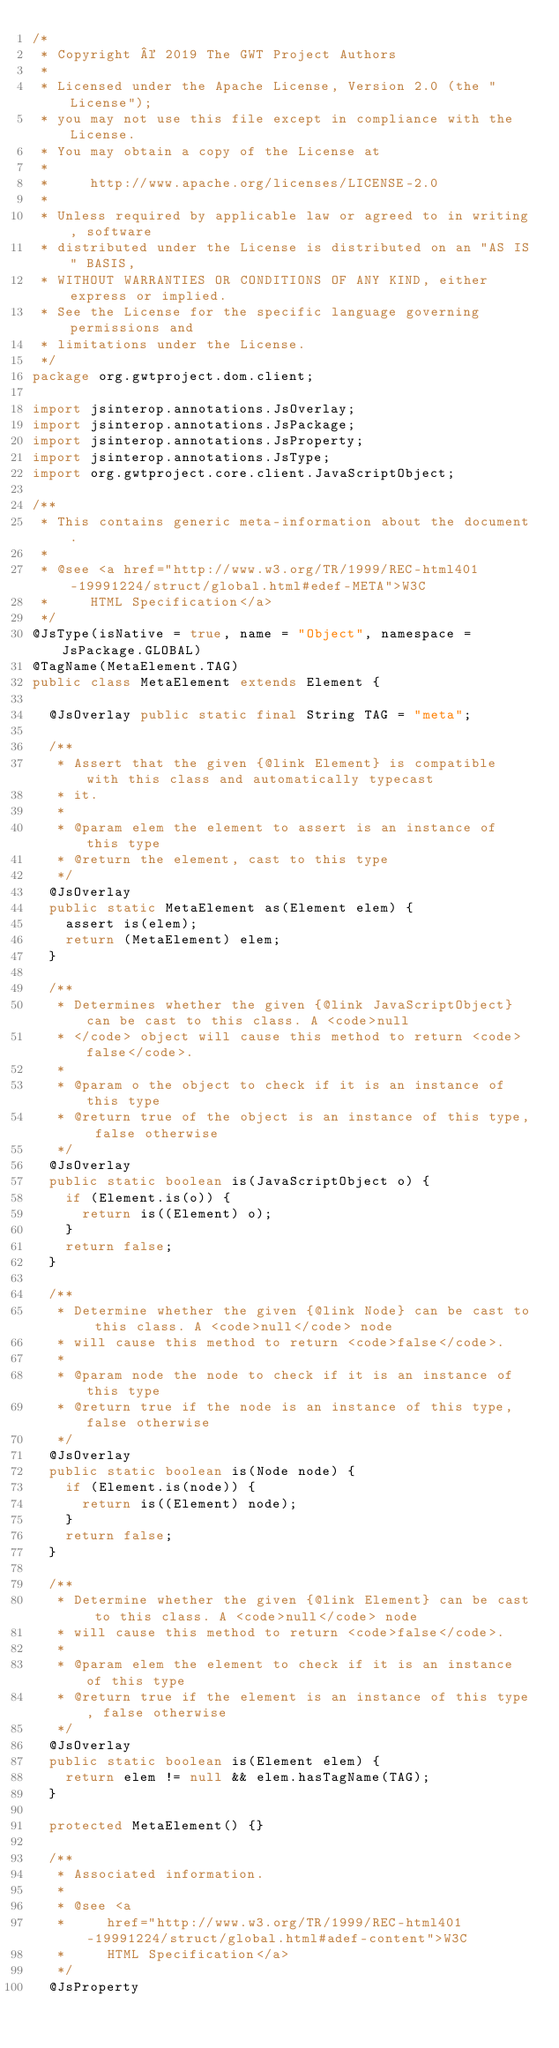<code> <loc_0><loc_0><loc_500><loc_500><_Java_>/*
 * Copyright © 2019 The GWT Project Authors
 *
 * Licensed under the Apache License, Version 2.0 (the "License");
 * you may not use this file except in compliance with the License.
 * You may obtain a copy of the License at
 *
 *     http://www.apache.org/licenses/LICENSE-2.0
 *
 * Unless required by applicable law or agreed to in writing, software
 * distributed under the License is distributed on an "AS IS" BASIS,
 * WITHOUT WARRANTIES OR CONDITIONS OF ANY KIND, either express or implied.
 * See the License for the specific language governing permissions and
 * limitations under the License.
 */
package org.gwtproject.dom.client;

import jsinterop.annotations.JsOverlay;
import jsinterop.annotations.JsPackage;
import jsinterop.annotations.JsProperty;
import jsinterop.annotations.JsType;
import org.gwtproject.core.client.JavaScriptObject;

/**
 * This contains generic meta-information about the document.
 *
 * @see <a href="http://www.w3.org/TR/1999/REC-html401-19991224/struct/global.html#edef-META">W3C
 *     HTML Specification</a>
 */
@JsType(isNative = true, name = "Object", namespace = JsPackage.GLOBAL)
@TagName(MetaElement.TAG)
public class MetaElement extends Element {

  @JsOverlay public static final String TAG = "meta";

  /**
   * Assert that the given {@link Element} is compatible with this class and automatically typecast
   * it.
   *
   * @param elem the element to assert is an instance of this type
   * @return the element, cast to this type
   */
  @JsOverlay
  public static MetaElement as(Element elem) {
    assert is(elem);
    return (MetaElement) elem;
  }

  /**
   * Determines whether the given {@link JavaScriptObject} can be cast to this class. A <code>null
   * </code> object will cause this method to return <code>false</code>.
   *
   * @param o the object to check if it is an instance of this type
   * @return true of the object is an instance of this type, false otherwise
   */
  @JsOverlay
  public static boolean is(JavaScriptObject o) {
    if (Element.is(o)) {
      return is((Element) o);
    }
    return false;
  }

  /**
   * Determine whether the given {@link Node} can be cast to this class. A <code>null</code> node
   * will cause this method to return <code>false</code>.
   *
   * @param node the node to check if it is an instance of this type
   * @return true if the node is an instance of this type, false otherwise
   */
  @JsOverlay
  public static boolean is(Node node) {
    if (Element.is(node)) {
      return is((Element) node);
    }
    return false;
  }

  /**
   * Determine whether the given {@link Element} can be cast to this class. A <code>null</code> node
   * will cause this method to return <code>false</code>.
   *
   * @param elem the element to check if it is an instance of this type
   * @return true if the element is an instance of this type, false otherwise
   */
  @JsOverlay
  public static boolean is(Element elem) {
    return elem != null && elem.hasTagName(TAG);
  }

  protected MetaElement() {}

  /**
   * Associated information.
   *
   * @see <a
   *     href="http://www.w3.org/TR/1999/REC-html401-19991224/struct/global.html#adef-content">W3C
   *     HTML Specification</a>
   */
  @JsProperty</code> 